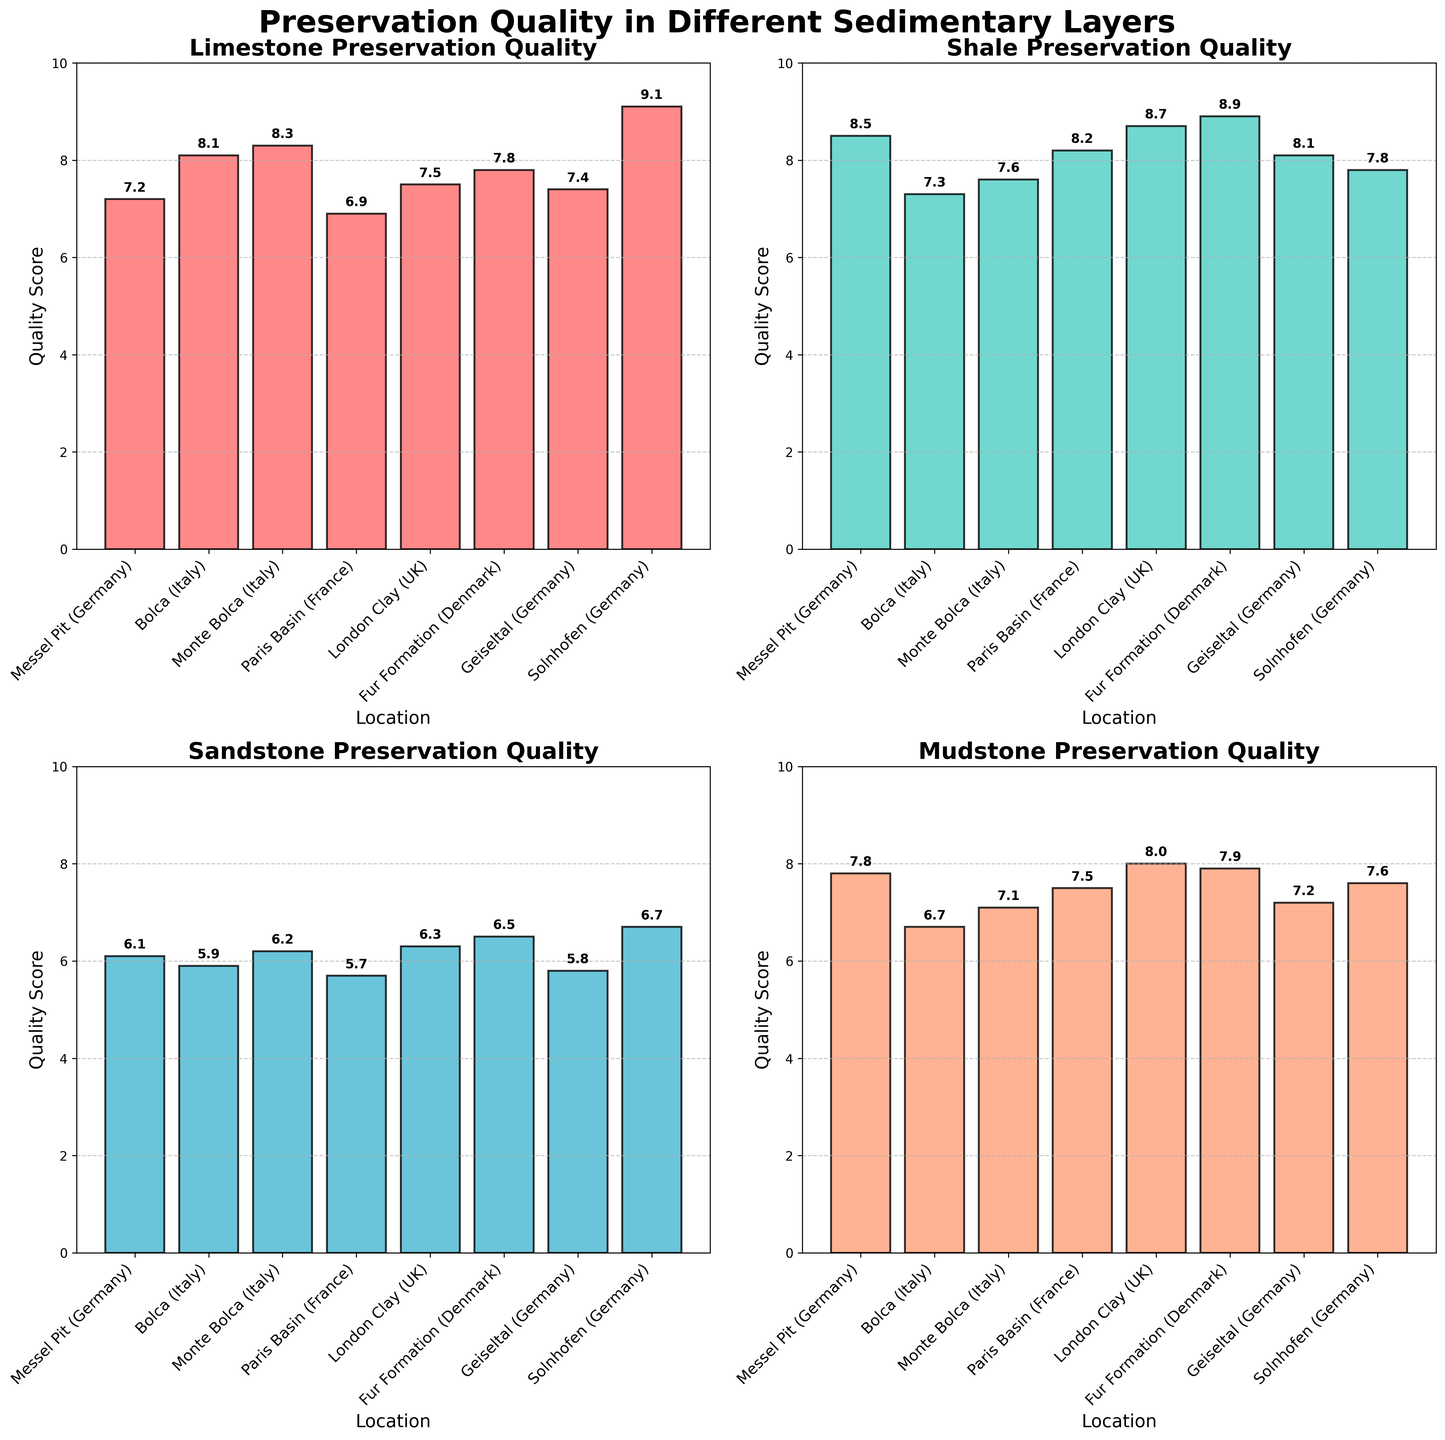Which location has the highest preservation quality in Limestone? Solnhofen (Germany) shows the highest bar in the Limestone subplot, indicating the highest preservation quality.
Answer: Solnhofen (Germany) What's the average preservation quality for Sandstone across all locations? Add the preservation quality values for Sandstone from all locations: 6.1 + 5.9 + 6.2 + 5.7 + 6.3 + 6.5 + 5.8 + 6.7 = 49.2. Divide by the number of locations: 49.2 / 8 = 6.15.
Answer: 6.15 Which sedimentary layer shows the highest preservation quality in the Fur Formation (Denmark)? In the subplot for each sedimentary layer, look for Fur Formation. Shale shows the highest value (8.9).
Answer: Shale Is the preservation quality of Shale higher in Paris Basin (France) or Geiseltal (Germany)? Compare the bars for Shale in the Paris Basin and Geiseltal. Paris Basin is higher (8.2 vs. 8.1).
Answer: Paris Basin (France) What is the difference in preservation quality between Mudstone and Limestone in Messel Pit (Germany)? In the subplots for Messel Pit, the preservation quality for Mudstone is 7.8 and for Limestone is 7.2. Difference: 7.8 - 7.2 = 0.6.
Answer: 0.6 What is the average preservation quality across all sedimentary layers for Monte Bolca (Italy)? Sum all preservation qualities for Monte Bolca: 8.3 (Limestone) + 7.6 (Shale) + 6.2 (Sandstone) + 7.1 (Mudstone) = 29.2. Divide by the number of layers: 29.2 / 4 = 7.3.
Answer: 7.3 How does the preservation quality in Mudstone for Solnhofen (Germany) compare to that in London Clay (UK)? Mudstone quality for Solnhofen is 7.6, and for London Clay, it is 8.0. London Clay has higher quality.
Answer: London Clay (UK) Which location has the lowest preservation quality in Sandstone? The shortest bar in the Sandstone subplot corresponds to Paris Basin (France) with 5.7.
Answer: Paris Basin (France) What is the range of preservation quality in Shale across all locations? Highest value in Shale is 8.9 (Fur Formation), and the lowest is 7.3 (Bolca). The range is 8.9 - 7.3 = 1.6.
Answer: 1.6 Which location has the most consistent (smallest range) preservation quality across different sedimentary layers? Calculate the range for each site and identify the smallest range: Messel Pit (1.7), Bolca (2.2), Monte Bolca (2.1), Paris Basin (2.5), London Clay (2.4), Fur Formation (2.4), Geiseltal (2.3), Solnhofen (1.5). Solnhofen has the smallest range.
Answer: Solnhofen (Germany) 